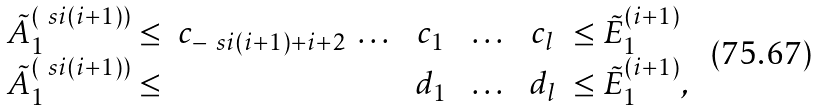<formula> <loc_0><loc_0><loc_500><loc_500>\begin{array} { r c c c c l } \tilde { A } ^ { ( \ s i ( i + 1 ) ) } _ { 1 } \leq & c _ { - \ s i ( i + 1 ) + i + 2 } \ \dots \ & c _ { 1 } & \ \dots \ & c _ { l } & \leq \tilde { E } ^ { ( i + 1 ) } _ { 1 } \\ \tilde { A } ^ { ( \ s i ( i + 1 ) ) } _ { 1 } \leq & & d _ { 1 } & \ \dots \ & d _ { l } & \leq \tilde { E } ^ { ( i + 1 ) } _ { 1 } , \end{array}</formula> 